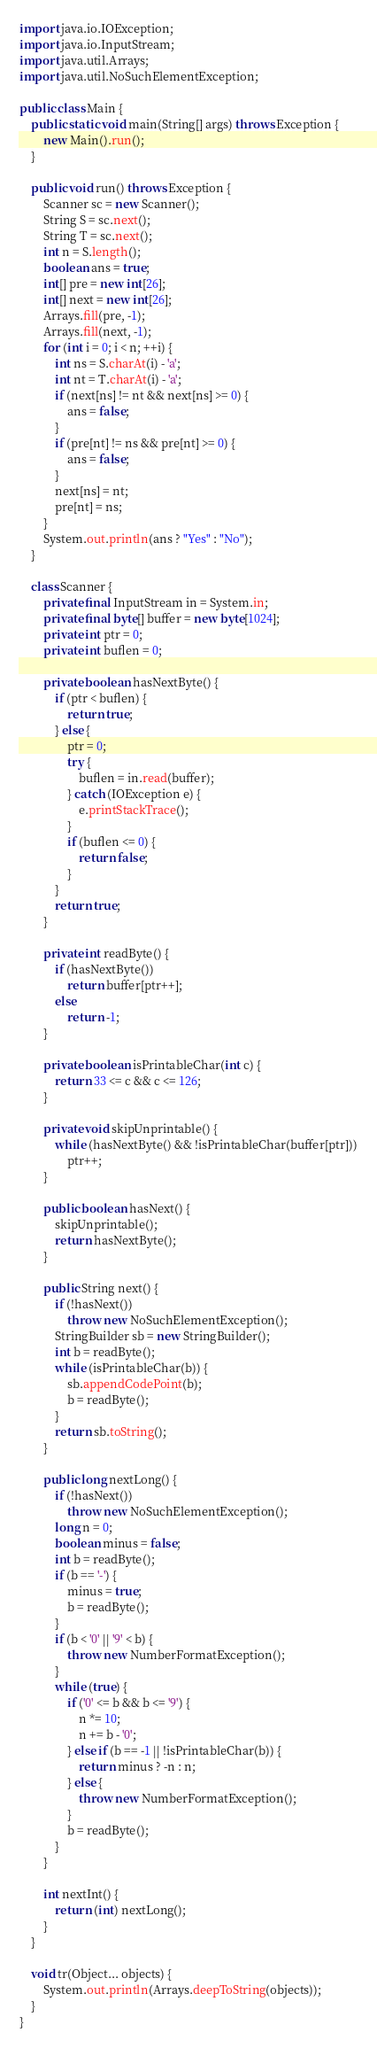<code> <loc_0><loc_0><loc_500><loc_500><_Java_>import java.io.IOException;
import java.io.InputStream;
import java.util.Arrays;
import java.util.NoSuchElementException;

public class Main {
	public static void main(String[] args) throws Exception {
		new Main().run();
	}

	public void run() throws Exception {
		Scanner sc = new Scanner();
		String S = sc.next();
		String T = sc.next();
		int n = S.length();
		boolean ans = true;
		int[] pre = new int[26];
		int[] next = new int[26];
		Arrays.fill(pre, -1);
		Arrays.fill(next, -1);
		for (int i = 0; i < n; ++i) {
			int ns = S.charAt(i) - 'a';
			int nt = T.charAt(i) - 'a';
			if (next[ns] != nt && next[ns] >= 0) {
				ans = false;
			}
			if (pre[nt] != ns && pre[nt] >= 0) {
				ans = false;
			}
			next[ns] = nt;
			pre[nt] = ns;
		}
		System.out.println(ans ? "Yes" : "No");
	}

	class Scanner {
		private final InputStream in = System.in;
		private final byte[] buffer = new byte[1024];
		private int ptr = 0;
		private int buflen = 0;

		private boolean hasNextByte() {
			if (ptr < buflen) {
				return true;
			} else {
				ptr = 0;
				try {
					buflen = in.read(buffer);
				} catch (IOException e) {
					e.printStackTrace();
				}
				if (buflen <= 0) {
					return false;
				}
			}
			return true;
		}

		private int readByte() {
			if (hasNextByte())
				return buffer[ptr++];
			else
				return -1;
		}

		private boolean isPrintableChar(int c) {
			return 33 <= c && c <= 126;
		}

		private void skipUnprintable() {
			while (hasNextByte() && !isPrintableChar(buffer[ptr]))
				ptr++;
		}

		public boolean hasNext() {
			skipUnprintable();
			return hasNextByte();
		}

		public String next() {
			if (!hasNext())
				throw new NoSuchElementException();
			StringBuilder sb = new StringBuilder();
			int b = readByte();
			while (isPrintableChar(b)) {
				sb.appendCodePoint(b);
				b = readByte();
			}
			return sb.toString();
		}

		public long nextLong() {
			if (!hasNext())
				throw new NoSuchElementException();
			long n = 0;
			boolean minus = false;
			int b = readByte();
			if (b == '-') {
				minus = true;
				b = readByte();
			}
			if (b < '0' || '9' < b) {
				throw new NumberFormatException();
			}
			while (true) {
				if ('0' <= b && b <= '9') {
					n *= 10;
					n += b - '0';
				} else if (b == -1 || !isPrintableChar(b)) {
					return minus ? -n : n;
				} else {
					throw new NumberFormatException();
				}
				b = readByte();
			}
		}

		int nextInt() {
			return (int) nextLong();
		}
	}

	void tr(Object... objects) {
		System.out.println(Arrays.deepToString(objects));
	}
}</code> 